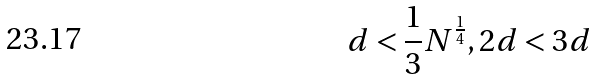<formula> <loc_0><loc_0><loc_500><loc_500>d < \frac { 1 } { 3 } N ^ { \frac { 1 } { 4 } } , 2 d < 3 d</formula> 